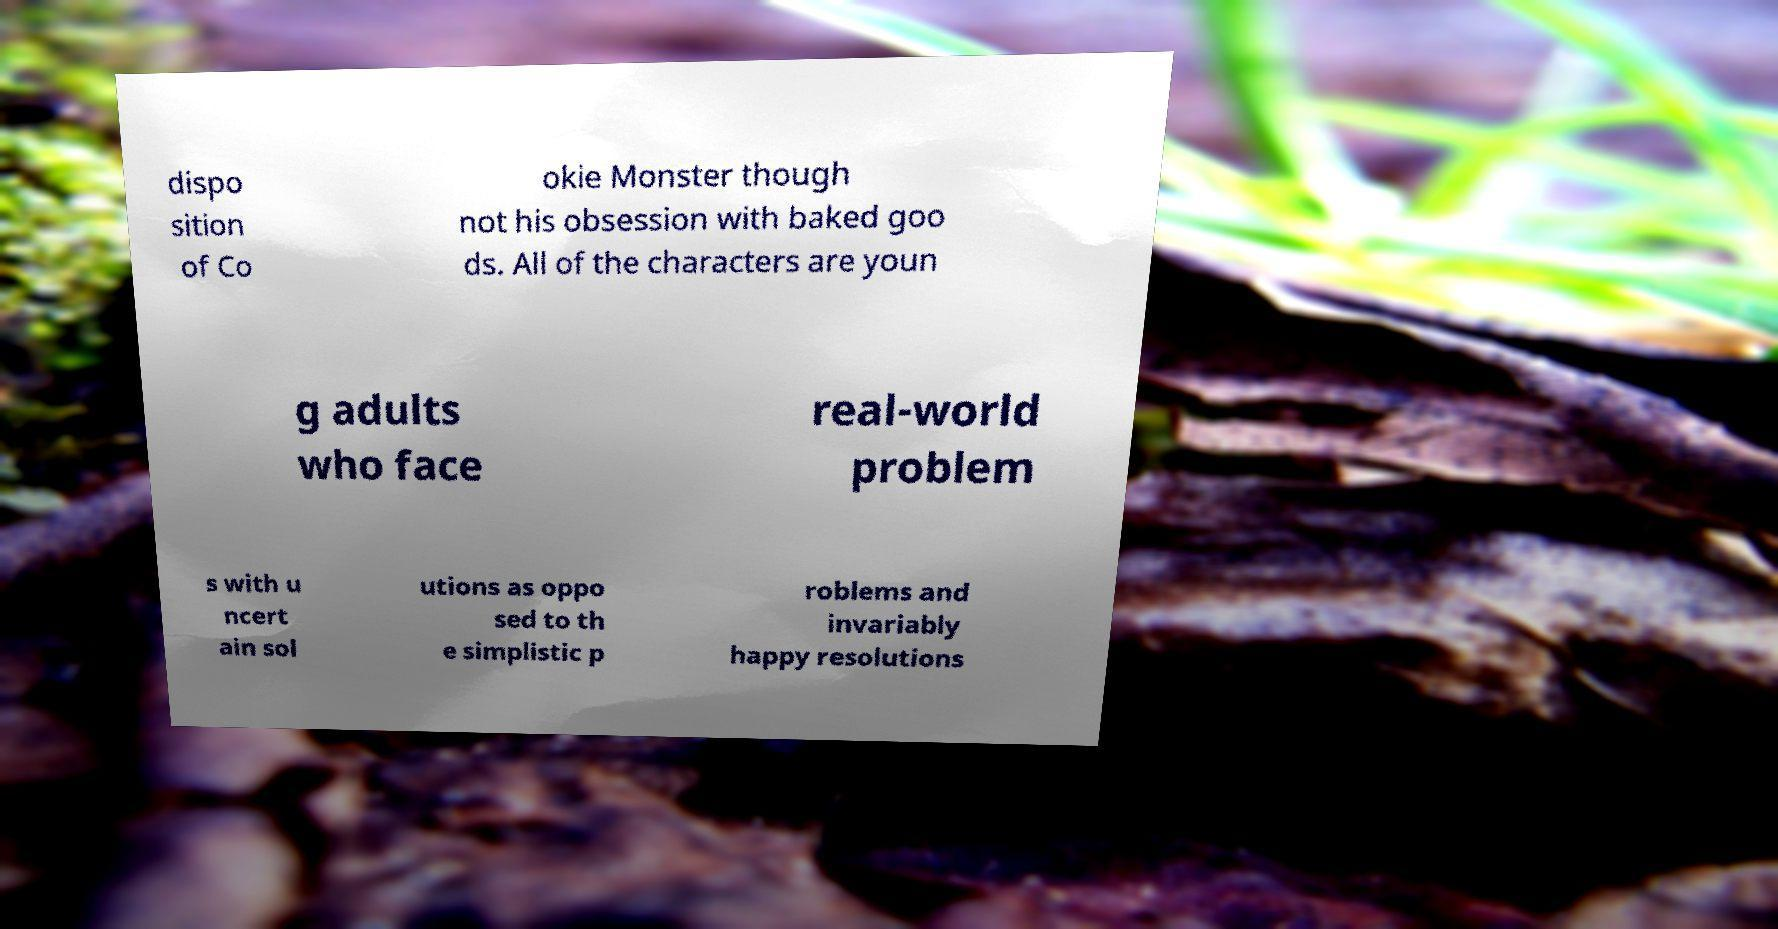Could you extract and type out the text from this image? dispo sition of Co okie Monster though not his obsession with baked goo ds. All of the characters are youn g adults who face real-world problem s with u ncert ain sol utions as oppo sed to th e simplistic p roblems and invariably happy resolutions 